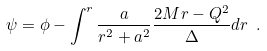<formula> <loc_0><loc_0><loc_500><loc_500>\psi = \phi - \int ^ { r } \frac { a } { r ^ { 2 } + a ^ { 2 } } \frac { 2 M r - Q ^ { 2 } } { \Delta } d r \ .</formula> 